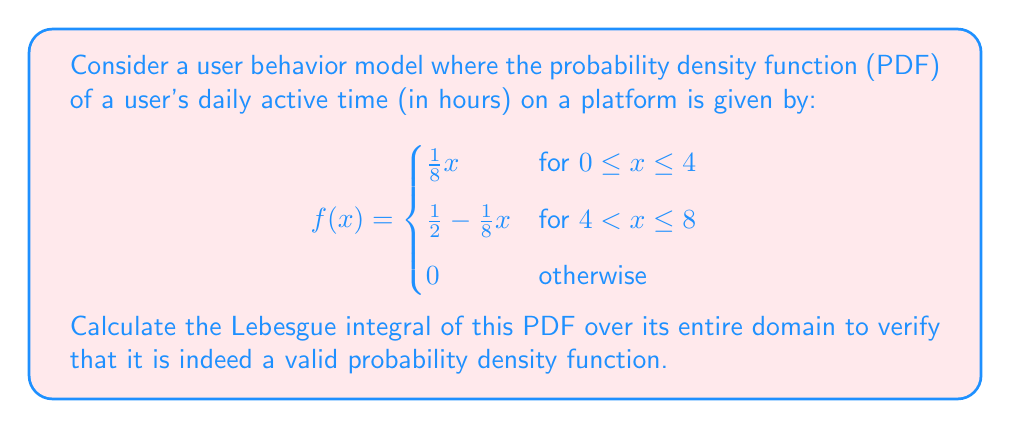Could you help me with this problem? To verify that $f(x)$ is a valid probability density function, we need to show that its Lebesgue integral over the entire domain equals 1. We'll calculate this integral step by step:

1) The domain of the function is split into two parts: $[0, 4]$ and $(4, 8]$. We'll integrate over each part separately and then sum the results.

2) For $0 \leq x \leq 4$:
   $$\int_0^4 \frac{1}{8}x \, dx = \frac{1}{8} \cdot \frac{x^2}{2} \Big|_0^4 = \frac{1}{16} \cdot 16 = 1$$

3) For $4 < x \leq 8$:
   $$\int_4^8 (\frac{1}{2} - \frac{1}{8}x) \, dx = \frac{1}{2}x - \frac{1}{16}x^2 \Big|_4^8 = (4 - 4) - (2 - 1) = 1$$

4) Sum the results:
   $$\int_0^4 \frac{1}{8}x \, dx + \int_4^8 (\frac{1}{2} - \frac{1}{8}x) \, dx = 1 + 1 = 2$$

The Lebesgue integral of $f(x)$ over its entire domain is 2, which means it's not a valid probability density function as is. To make it valid, we need to normalize it by dividing the entire function by 2.

The corrected PDF would be:

$$f(x) = \begin{cases}
\frac{1}{16}x & \text{for } 0 \leq x \leq 4 \\
\frac{1}{4} - \frac{1}{16}x & \text{for } 4 < x \leq 8 \\
0 & \text{otherwise}
\end{cases}$$

We can verify that the integral of this corrected function over its domain is indeed 1:

$$\int_0^4 \frac{1}{16}x \, dx + \int_4^8 (\frac{1}{4} - \frac{1}{16}x) \, dx = \frac{1}{2} + \frac{1}{2} = 1$$
Answer: The original function is not a valid PDF. The corrected PDF is:

$$f(x) = \begin{cases}
\frac{1}{16}x & \text{for } 0 \leq x \leq 4 \\
\frac{1}{4} - \frac{1}{16}x & \text{for } 4 < x \leq 8 \\
0 & \text{otherwise}
\end{cases}$$

The Lebesgue integral of this corrected PDF over its entire domain is 1, confirming it is a valid probability density function. 